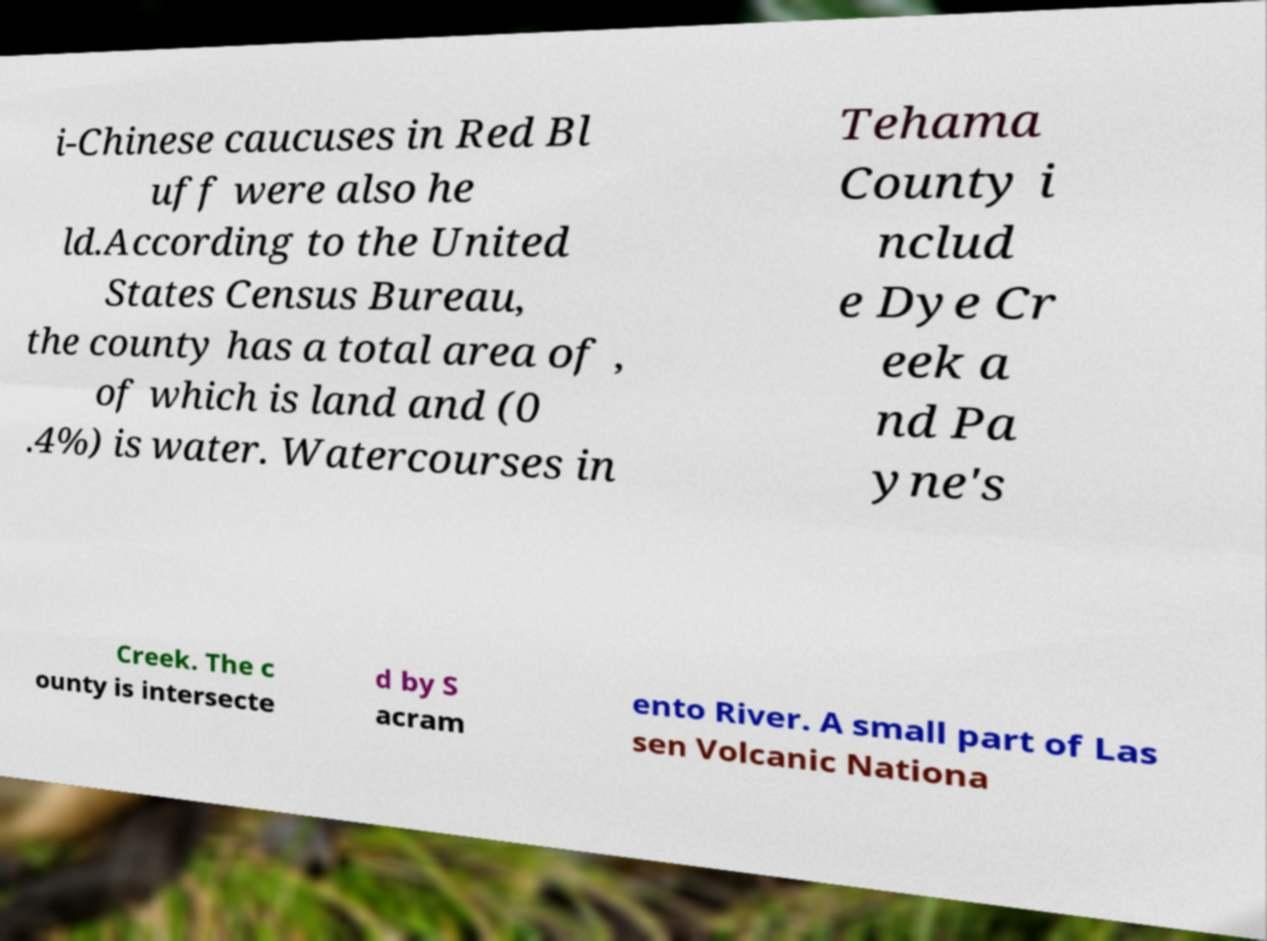Can you accurately transcribe the text from the provided image for me? i-Chinese caucuses in Red Bl uff were also he ld.According to the United States Census Bureau, the county has a total area of , of which is land and (0 .4%) is water. Watercourses in Tehama County i nclud e Dye Cr eek a nd Pa yne's Creek. The c ounty is intersecte d by S acram ento River. A small part of Las sen Volcanic Nationa 